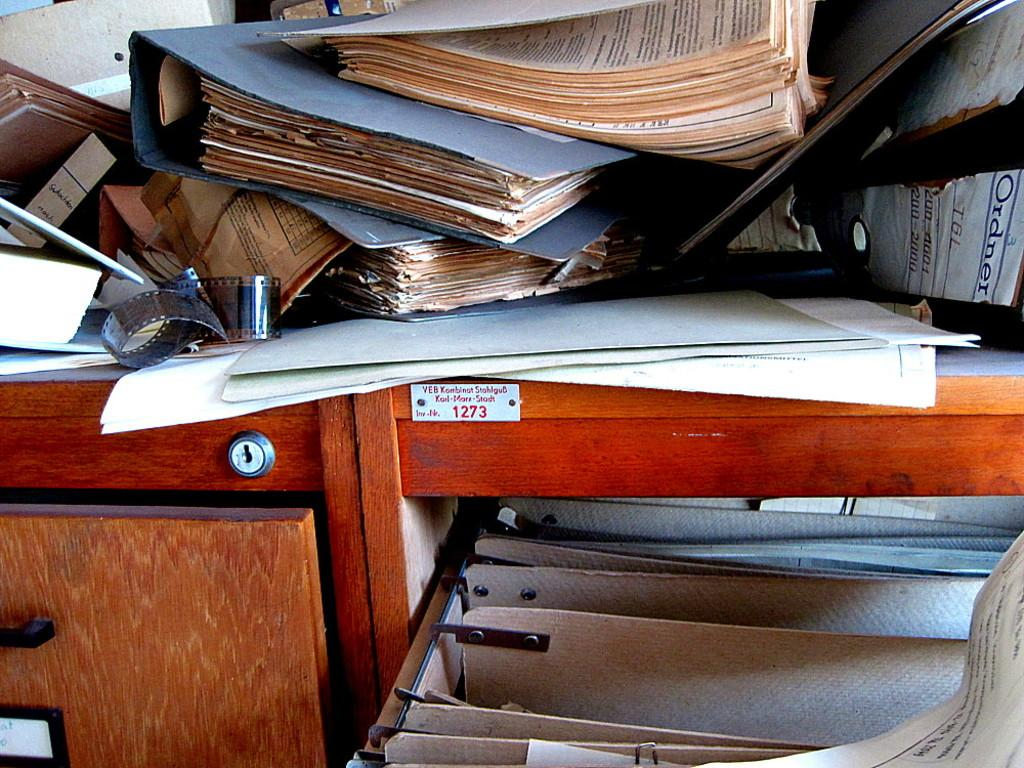What piece of furniture is present in the image? There is a table in the image. What items are placed on the table? There are files on the table. How many cracks can be seen on the table in the image? There is no mention of any cracks on the table in the provided facts, so we cannot determine the number of cracks from the image. 